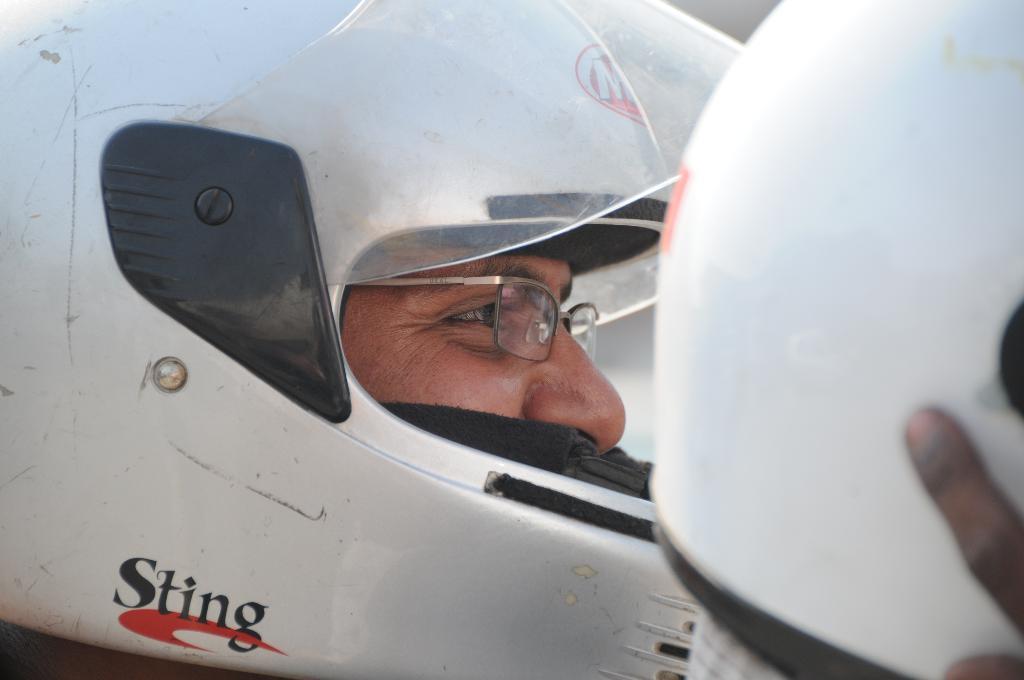How would you summarize this image in a sentence or two? In this image I can see the person's face and the person is wearing the helmet and the helmet is in white color. 